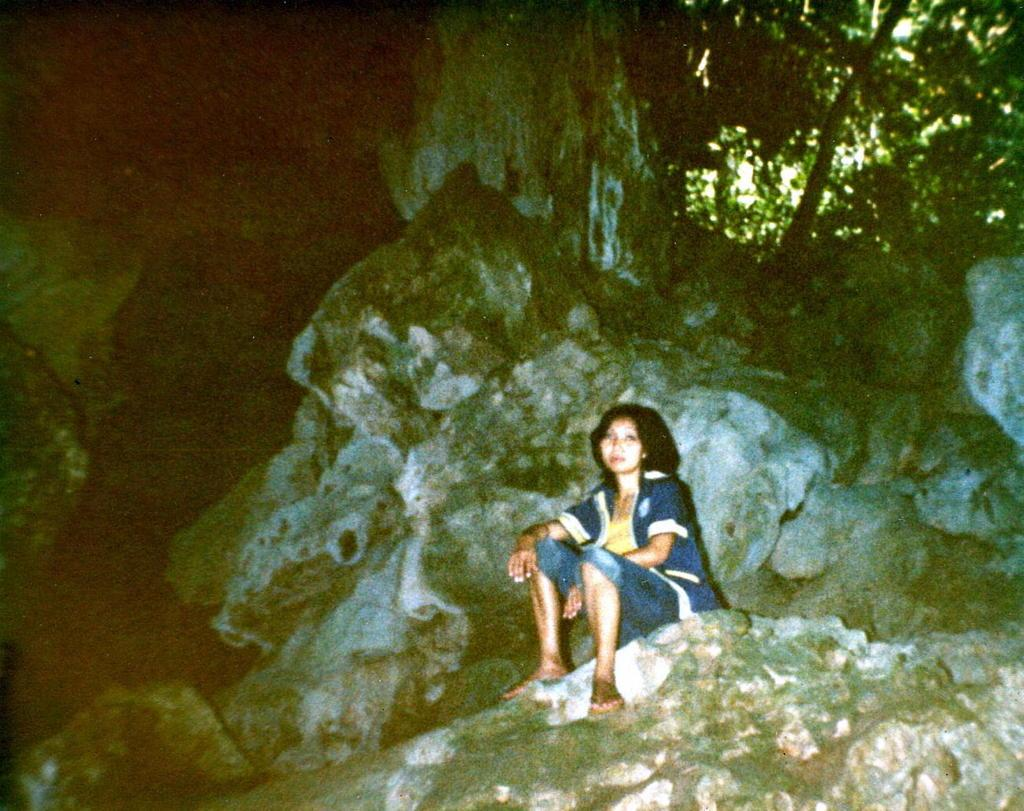Who is present in the image? There is a woman in the image. What is the woman wearing? The woman is wearing a yellow dress, a blue jacket, and blue jeans. What is the woman doing in the image? The woman is sitting on a rock. What can be seen in the background of the image? There is a tree and rocks in the background of the image. What type of meal is the woman eating in the image? There is no meal present in the image; the woman is sitting on a rock. Can you tell me where the library is located in the image? There is no library present in the image; it features a woman sitting on a rock with a tree and rocks in the background. 